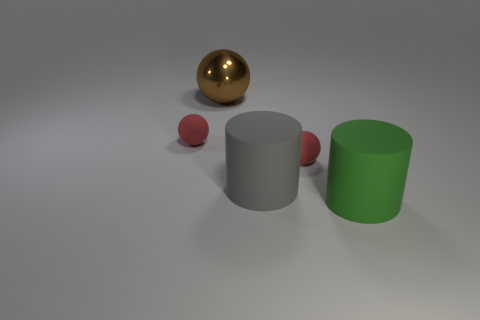Subtract all big spheres. How many spheres are left? 2 Add 2 purple rubber spheres. How many objects exist? 7 Subtract all brown spheres. How many spheres are left? 2 Subtract all blue blocks. How many red balls are left? 2 Subtract 0 yellow blocks. How many objects are left? 5 Subtract all cylinders. How many objects are left? 3 Subtract 3 spheres. How many spheres are left? 0 Subtract all brown spheres. Subtract all cyan cubes. How many spheres are left? 2 Subtract all metallic things. Subtract all shiny objects. How many objects are left? 3 Add 4 brown things. How many brown things are left? 5 